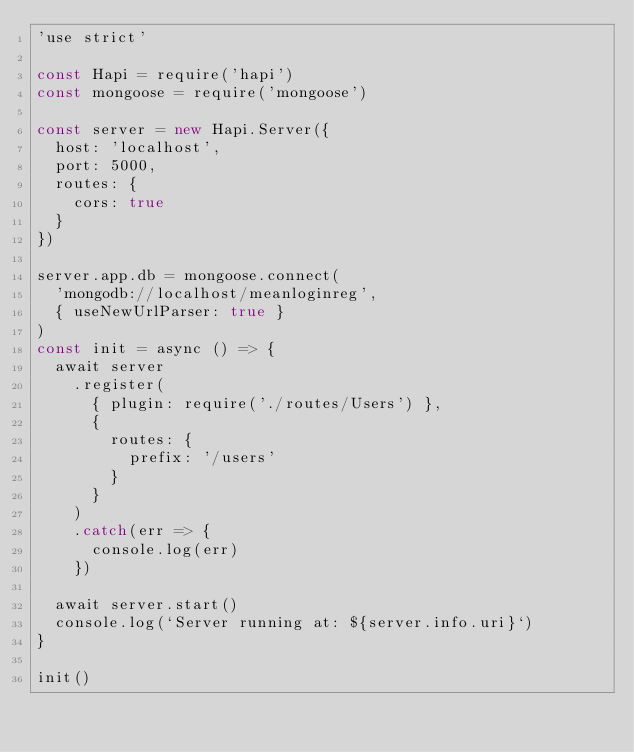<code> <loc_0><loc_0><loc_500><loc_500><_JavaScript_>'use strict'

const Hapi = require('hapi')
const mongoose = require('mongoose')

const server = new Hapi.Server({
  host: 'localhost',
  port: 5000,
  routes: {
    cors: true
  }
})

server.app.db = mongoose.connect(
  'mongodb://localhost/meanloginreg',
  { useNewUrlParser: true }
)
const init = async () => {
  await server
    .register(
      { plugin: require('./routes/Users') },
      {
        routes: {
          prefix: '/users'
        }
      }
    )
    .catch(err => {
      console.log(err)
    })

  await server.start()
  console.log(`Server running at: ${server.info.uri}`)
}

init()
</code> 